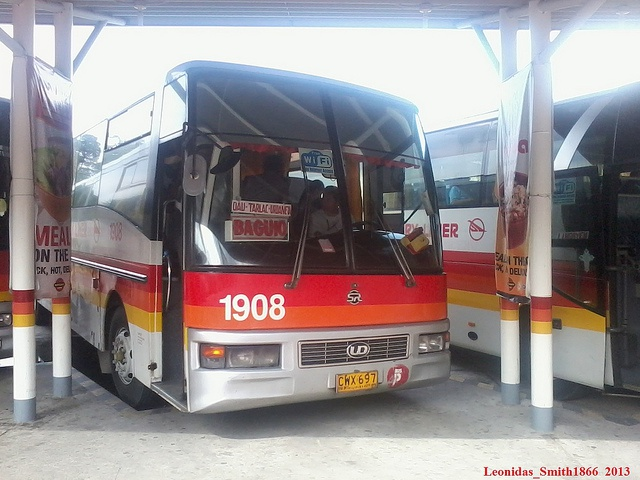Describe the objects in this image and their specific colors. I can see bus in gray, black, lightgray, and darkgray tones, bus in gray, black, darkgray, and lightblue tones, bus in gray, black, darkgray, and maroon tones, people in black and gray tones, and people in gray and black tones in this image. 